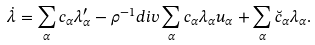Convert formula to latex. <formula><loc_0><loc_0><loc_500><loc_500>\dot { \lambda } = \sum _ { \alpha } c _ { \alpha } \lambda _ { \alpha } ^ { \prime } - \rho ^ { - 1 } d i v \sum _ { \alpha } c _ { \alpha } \lambda _ { \alpha } u _ { \alpha } + \sum _ { \alpha } \breve { c } _ { \alpha } \lambda _ { \alpha } .</formula> 